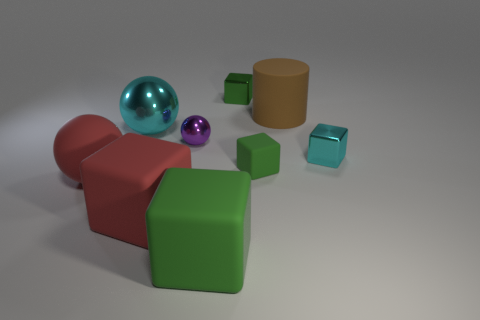Subtract all green blocks. How many were subtracted if there are1green blocks left? 2 Subtract all cyan cylinders. How many green cubes are left? 3 Subtract all cyan metal blocks. How many blocks are left? 4 Subtract all red cubes. How many cubes are left? 4 Subtract all yellow blocks. Subtract all green cylinders. How many blocks are left? 5 Subtract all balls. How many objects are left? 6 Subtract all small green matte things. Subtract all small green cubes. How many objects are left? 6 Add 5 small cubes. How many small cubes are left? 8 Add 1 purple metallic things. How many purple metallic things exist? 2 Subtract 0 purple blocks. How many objects are left? 9 